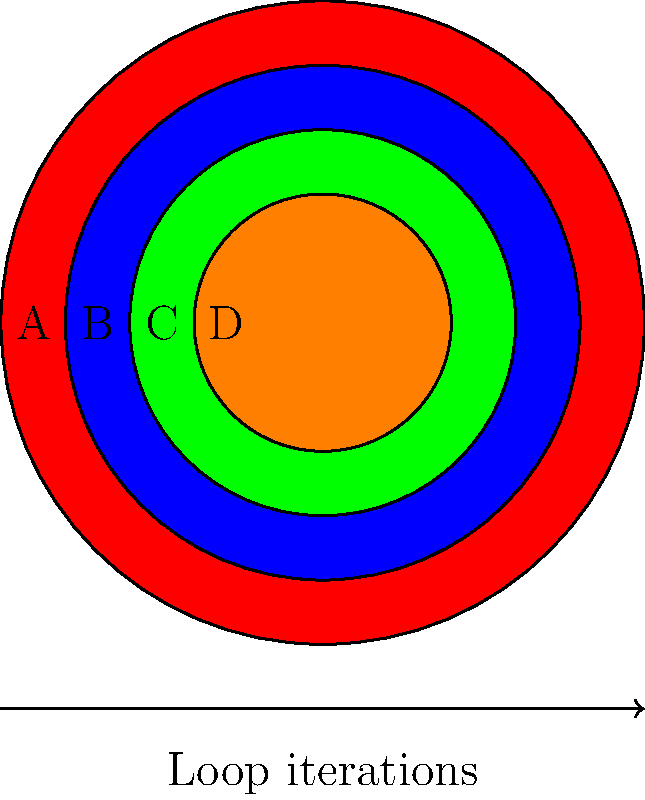In a Google Sheets script, you're tasked with creating a nested loop structure that generates a pattern similar to the concentric circles shown above. Each circle represents a loop iteration, with the outermost circle being the first iteration. The color of each circle is determined by a conditional statement within the inner loop.

Given the following color-to-condition mapping:
- Red: if(i % 4 == 0)
- Blue: else if(i % 4 == 1)
- Green: else if(i % 4 == 2)
- Orange: else

What would be the correct order of labels (A, B, C, D) to represent the execution of the nested loops from outer to inner? To solve this puzzle, we need to analyze the nested loop structure and conditional statements:

1. The outermost circle represents the first iteration of the outer loop. Its color is red, which corresponds to the condition `if(i % 4 == 0)`. This means A represents the outermost loop.

2. Moving inward, the second circle is blue. This matches the condition `else if(i % 4 == 1)`, indicating that B represents the second iteration.

3. The third circle from the outside is green, corresponding to `else if(i % 4 == 2)`. Therefore, C represents the third iteration.

4. The innermost circle is orange, which matches the `else` condition. This means D represents the innermost loop or the last iteration.

The nested loop structure would execute from the outermost to the innermost, following the pattern of the concentric circles. Thus, the correct order of labels representing the execution of the nested loops from outer to inner is A, B, C, D.
Answer: A, B, C, D 